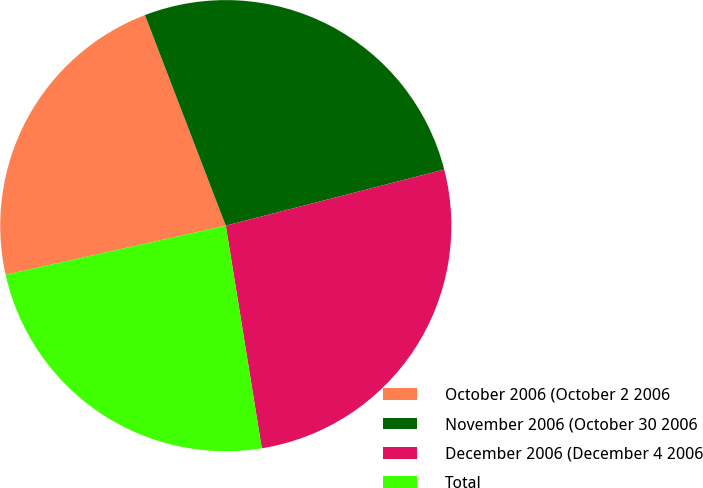Convert chart. <chart><loc_0><loc_0><loc_500><loc_500><pie_chart><fcel>October 2006 (October 2 2006<fcel>November 2006 (October 30 2006<fcel>December 2006 (December 4 2006<fcel>Total<nl><fcel>22.66%<fcel>26.83%<fcel>26.45%<fcel>24.06%<nl></chart> 